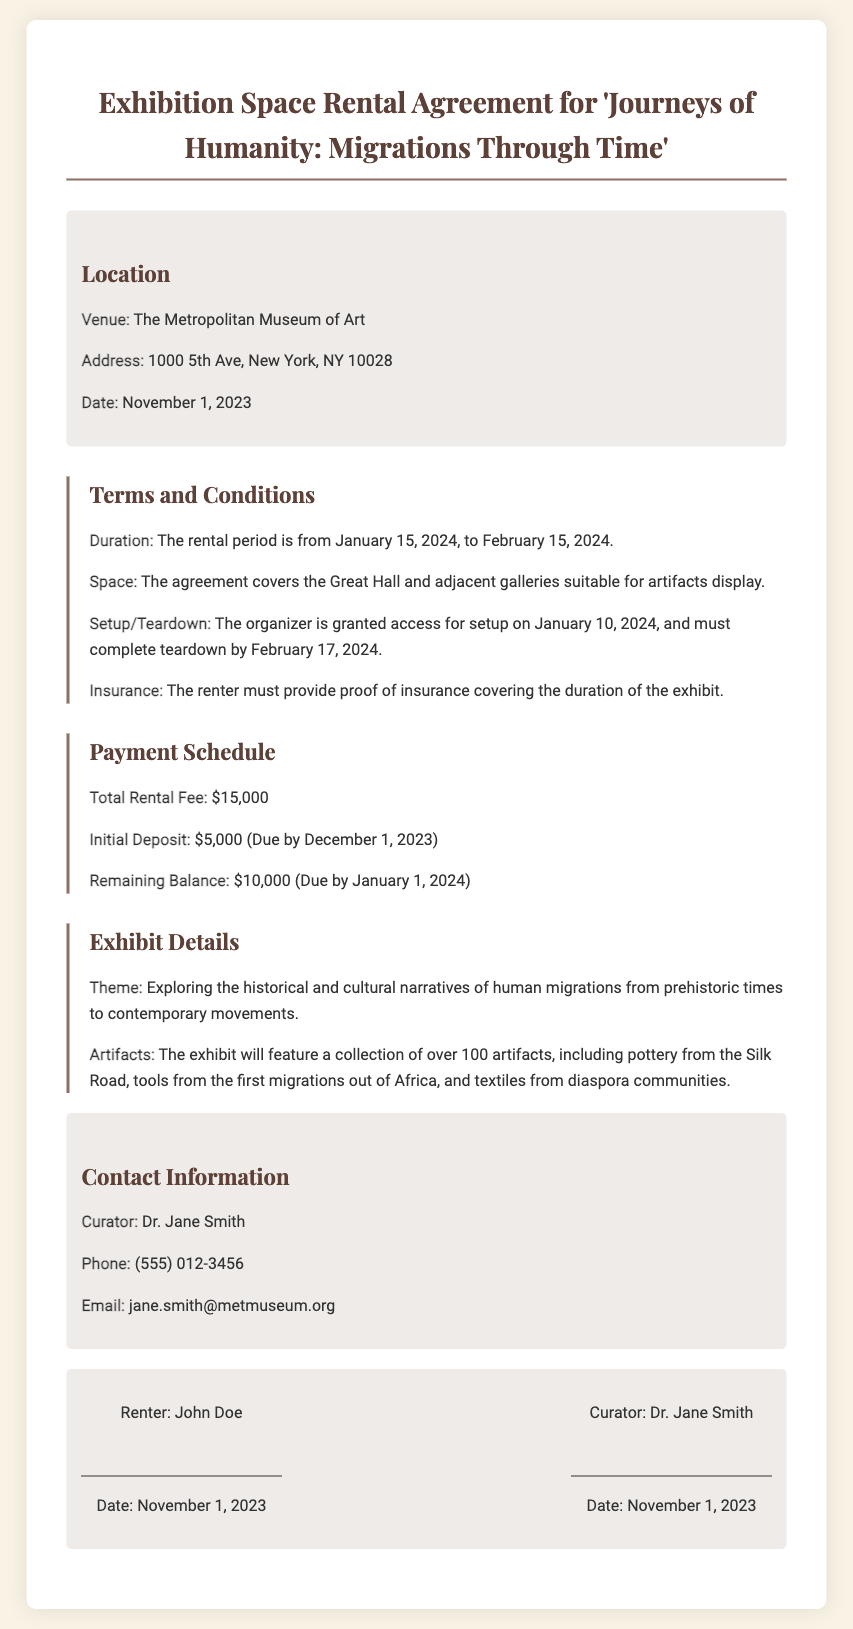what is the total rental fee? The total rental fee outlined in the document is specified in the payment section.
Answer: $15,000 what is the rental duration? The rental duration is mentioned under the terms and conditions section.
Answer: January 15, 2024, to February 15, 2024 who is the curator? The document provides the name of the curator in the contact information section.
Answer: Dr. Jane Smith what is the initial deposit amount? The initial deposit is specified in the payment schedule within the document.
Answer: $5,000 what is the address of the venue? The address is stated in the location section of the document.
Answer: 1000 5th Ave, New York, NY 10028 when is the remaining balance due? The due date for the remaining balance is provided in the payment schedule.
Answer: January 1, 2024 who must provide proof of insurance? The obligation to provide proof of insurance is mentioned in the terms and conditions section.
Answer: The renter what theme does the exhibit focus on? The exhibit theme is described in the exhibit details section.
Answer: Exploring the historical and cultural narratives of human migrations when is the teardown completion deadline? The teardown deadline is stated in the terms and conditions regarding setup and teardown.
Answer: February 17, 2024 